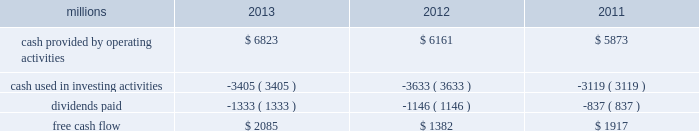Increase in dividends paid .
Free cash flow is defined as cash provided by operating activities less cash used in investing activities and dividends paid .
Free cash flow is not considered a financial measure under accounting principles generally accepted in the u.s .
( gaap ) by sec regulation g and item 10 of sec regulation s-k and may not be defined and calculated by other companies in the same manner .
We believe free cash flow is important to management and investors in evaluating our financial performance and measures our ability to generate cash without additional external financings .
Free cash flow should be considered in addition to , rather than as a substitute for , cash provided by operating activities .
The table reconciles cash provided by operating activities ( gaap measure ) to free cash flow ( non-gaap measure ) : millions 2013 2012 2011 .
2014 outlook f0b7 safety 2013 operating a safe railroad benefits our employees , our customers , our shareholders , and the communities we serve .
We will continue using a multi-faceted approach to safety , utilizing technology , risk assessment , quality control , training and employee engagement , and targeted capital investments .
We will continue using and expanding the deployment of total safety culture and courage to care throughout our operations , which allows us to identify and implement best practices for employee and operational safety .
Derailment prevention and the reduction of grade crossing incidents are also critical aspects of our safety programs .
We will continue our efforts to increase detection of rail defects ; improve or close crossings ; and educate the public and law enforcement agencies about crossing safety through a combination of our own programs ( including risk assessment strategies ) , various industry programs and local community activities across our network .
F0b7 network operations 2013 we believe the railroad is capable of handling growing volumes while providing high levels of customer service .
Our track structure is in excellent condition , and certain sections of our network have surplus line and terminal capacity .
We are in a solid resource position , with sufficient supplies of locomotives , freight cars and crews to support growth .
F0b7 fuel prices 2013 uncertainty about the economy makes projections of fuel prices difficult .
We again could see volatile fuel prices during the year , as they are sensitive to global and u.s .
Domestic demand , refining capacity , geopolitical events , weather conditions and other factors .
To reduce the impact of fuel price on earnings , we will continue seeking cost recovery from our customers through our fuel surcharge programs and expanding our fuel conservation efforts .
F0b7 capital plan 2013 in 2014 , we plan to make total capital investments of approximately $ 3.9 billion , including expenditures for positive train control ( ptc ) , which may be revised if business conditions warrant or if new laws or regulations affect our ability to generate sufficient returns on these investments .
( see further discussion in this item 7 under liquidity and capital resources 2013 capital plan. ) f0b7 positive train control 2013 in response to a legislative mandate to implement ptc by the end of 2015 , we have invested $ 1.2 billion in capital expenditures and plan to spend an additional $ 450 million during 2014 on developing and deploying ptc .
We currently estimate that ptc , in accordance with implementing rules issued by the federal rail administration ( fra ) , will cost us approximately $ 2 billion by the end of the project .
This includes costs for installing the new system along our tracks , upgrading locomotives to work with the new system , and adding digital data communication equipment to integrate the various components of the system and achieve interoperability for the industry .
Although it is unlikely that the rail industry will meet the current mandatory 2015 deadline ( as the fra indicated in its 2012 report to congress ) , we are making a good faith effort to do so and we are working closely with regulators as we implement this new technology. .
What percentage of cash provided by operating activities were dividends paid in 2013? 
Computations: (1333 / 6823)
Answer: 0.19537. 